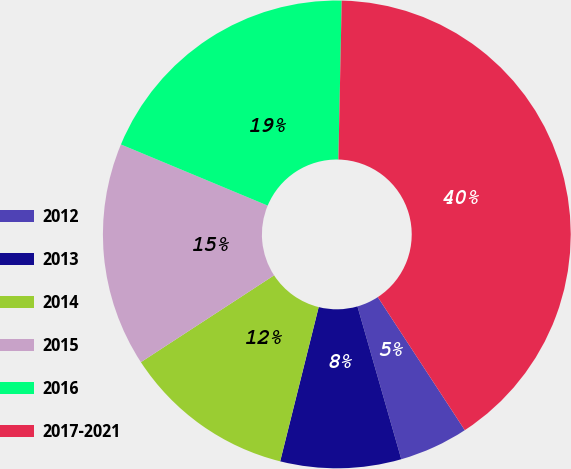Convert chart. <chart><loc_0><loc_0><loc_500><loc_500><pie_chart><fcel>2012<fcel>2013<fcel>2014<fcel>2015<fcel>2016<fcel>2017-2021<nl><fcel>4.77%<fcel>8.34%<fcel>11.91%<fcel>15.48%<fcel>19.05%<fcel>40.45%<nl></chart> 